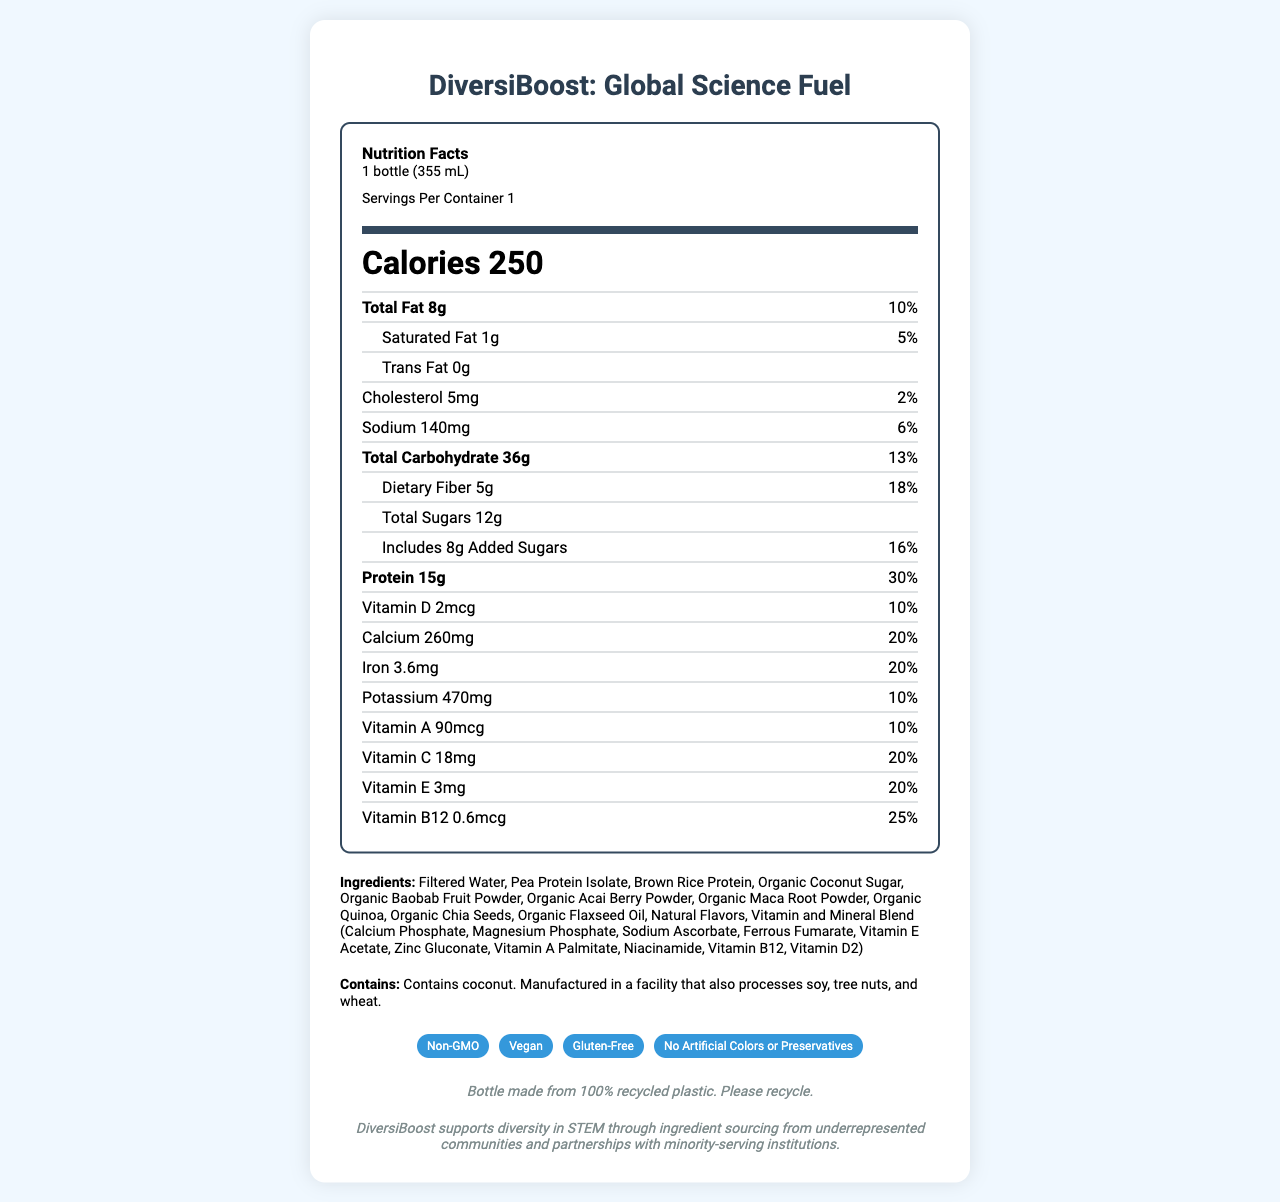what is the serving size of DiversiBoost: Global Science Fuel? The serving size is explicitly stated under the "Nutrition Facts" header.
Answer: 1 bottle (355 mL) how many calories are in one serving? The calorie content is prominently displayed in the center of the nutrition facts.
Answer: 250 how much vitamin D does one serving contain? The amount of Vitamin D per serving is listed in the vitamin and mineral section of the nutrition label.
Answer: 2mcg how many grams of total sugars are there in one serving of DiversiBoost? The total sugars are specifically listed in the carbohydrate section of the nutrition facts.
Answer: 12g what percentage of the daily value of protein is provided by one serving? The daily value percentage for protein is clearly stated next to its amount.
Answer: 30% which special features does DiversiBoost: Global Science Fuel have? A. Gluten-Free, Organic B. Non-GMO, Vegan C. No Artificial Colors, Contains Nuts D. Only available in winter The special features section mentions "Non-GMO" and "Vegan."
Answer: B how many servings are there in one container? A. 1 B. 2 C. 3 D. 4 The document states "Servings Per Container 1" under the "Nutrition Facts" header.
Answer: A is DiversiBoost suitable for vegans? The special features section explicitly states that the product is "Vegan."
Answer: Yes does DiversiBoost contain any cholesterol? The nutrition facts list 5mg of cholesterol, which is 2% of the daily value.
Answer: Yes describe the main idea of the document The document offers comprehensive nutritional information, special features, and other relevant details about the product, emphasizing its support for diversity and sustainability.
Answer: The document provides a detailed nutrition facts label for DiversiBoost: Global Science Fuel, a meal replacement drink designed to support diversity in STEM fields. It highlights the product's nutritional content, including vitamins, minerals, and special features such as being non-GMO, vegan, and gluten-free. The document also includes information on ingredient sourcing, allergen information, and sustainability initiatives. is DiversiBoost gluten-free? One of the special features listed is that the product is "Gluten-Free."
Answer: Yes what are the main sources of protein in DiversiBoost: Global Science Fuel? The ingredient list specifies "Pea Protein Isolate" and "Brown Rice Protein" as the first two ingredients.
Answer: Pea Protein Isolate, Brown Rice Protein how much added sugar does one serving contain and what percentage of the daily value does this represent? The nutrition facts list 8g of added sugars, which is 16% of the daily value.
Answer: 8g, 16% is DiversiBoost high in sodium? The sodium content is 140mg, which is 6% of the daily value. This is relatively low compared to other nutrients.
Answer: No from which communities does DiversiBoost source its ingredients? The document states that ingredients are sourced from underrepresented communities, but it does not specify which communities.
Answer: Not specified 